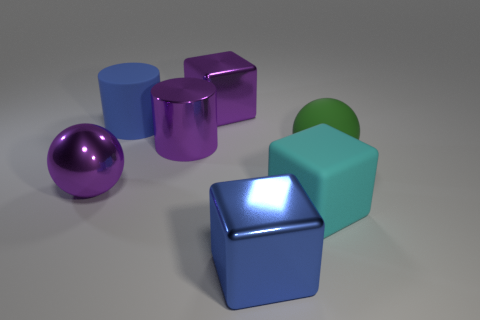Add 1 large matte objects. How many objects exist? 8 Subtract all cubes. How many objects are left? 4 Add 1 big green things. How many big green things exist? 2 Subtract 1 purple cubes. How many objects are left? 6 Subtract all small blue matte cubes. Subtract all big cyan blocks. How many objects are left? 6 Add 4 shiny cylinders. How many shiny cylinders are left? 5 